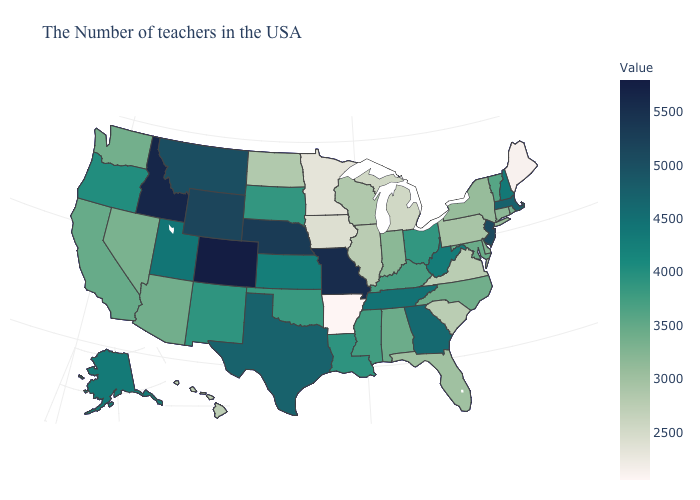Does New Jersey have a lower value than Pennsylvania?
Keep it brief. No. Which states have the lowest value in the USA?
Quick response, please. Arkansas. Does South Carolina have a lower value than Arkansas?
Short answer required. No. Does the map have missing data?
Answer briefly. No. Among the states that border New Mexico , which have the highest value?
Short answer required. Colorado. Among the states that border Michigan , does Ohio have the lowest value?
Concise answer only. No. Does Colorado have the highest value in the USA?
Answer briefly. Yes. 